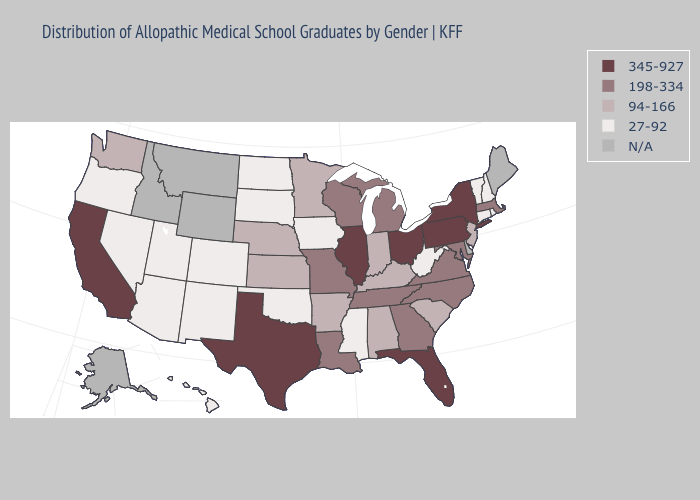Which states have the lowest value in the West?
Give a very brief answer. Arizona, Colorado, Hawaii, Nevada, New Mexico, Oregon, Utah. Name the states that have a value in the range N/A?
Keep it brief. Alaska, Delaware, Idaho, Maine, Montana, Wyoming. Does the map have missing data?
Quick response, please. Yes. What is the lowest value in states that border Virginia?
Short answer required. 27-92. Which states have the lowest value in the USA?
Write a very short answer. Arizona, Colorado, Connecticut, Hawaii, Iowa, Mississippi, Nevada, New Hampshire, New Mexico, North Dakota, Oklahoma, Oregon, Rhode Island, South Dakota, Utah, Vermont, West Virginia. What is the highest value in states that border Mississippi?
Answer briefly. 198-334. Name the states that have a value in the range N/A?
Quick response, please. Alaska, Delaware, Idaho, Maine, Montana, Wyoming. Does New York have the highest value in the USA?
Short answer required. Yes. Does Pennsylvania have the lowest value in the Northeast?
Keep it brief. No. Among the states that border Missouri , which have the highest value?
Answer briefly. Illinois. Does New York have the highest value in the USA?
Answer briefly. Yes. What is the value of Rhode Island?
Give a very brief answer. 27-92. What is the value of Montana?
Quick response, please. N/A. Which states have the highest value in the USA?
Write a very short answer. California, Florida, Illinois, New York, Ohio, Pennsylvania, Texas. 